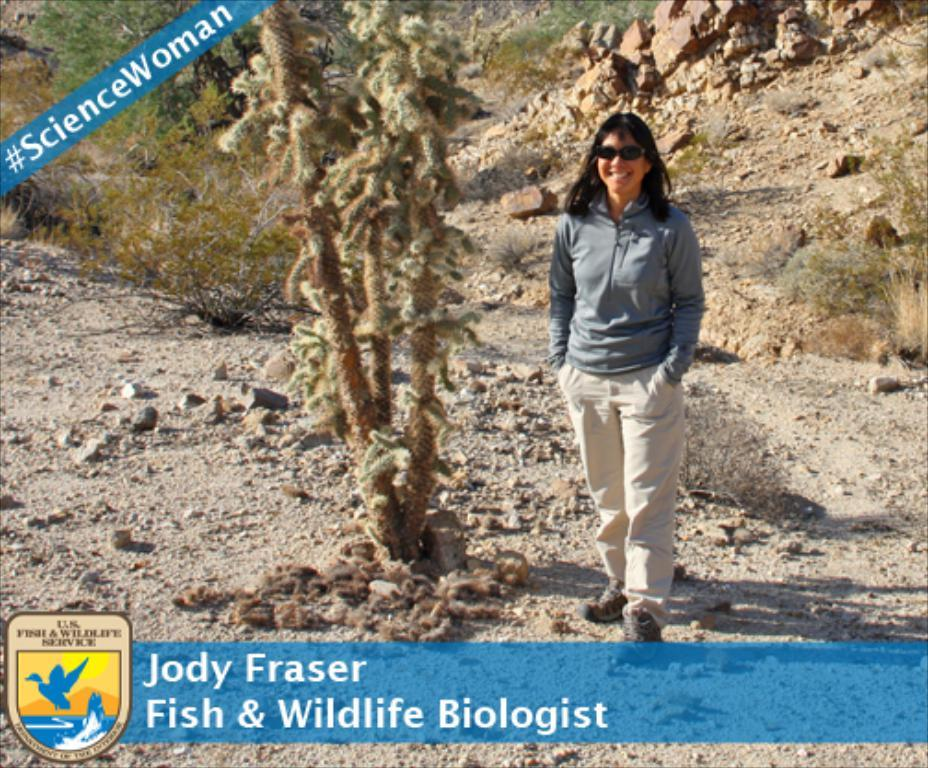What is the person in the image doing? The person in the image is standing and smiling. What can be seen in the background of the image? There are plants, rocks, and grass in the background of the image. Are there any watermarks on the image? Yes, there are watermarks on the image. What type of animal is waving the flag in the image? There is no animal or flag present in the image. What time is indicated by the clock in the image? There is no clock present in the image. 